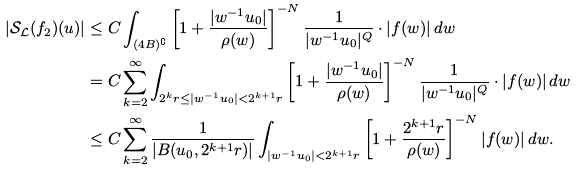Convert formula to latex. <formula><loc_0><loc_0><loc_500><loc_500>\left | \mathcal { S } _ { \mathcal { L } } ( f _ { 2 } ) ( u ) \right | & \leq C \int _ { ( 4 B ) ^ { \complement } } \left [ 1 + \frac { | w ^ { - 1 } u _ { 0 } | } { \rho ( w ) } \right ] ^ { - N } \frac { 1 } { | w ^ { - 1 } u _ { 0 } | ^ { Q } } \cdot | f ( w ) | \, d w \\ & = C \sum _ { k = 2 } ^ { \infty } \int _ { 2 ^ { k } r \leq | w ^ { - 1 } u _ { 0 } | < 2 ^ { k + 1 } r } \left [ 1 + \frac { | w ^ { - 1 } u _ { 0 } | } { \rho ( w ) } \right ] ^ { - N } \frac { 1 } { | w ^ { - 1 } u _ { 0 } | ^ { Q } } \cdot | f ( w ) | \, d w \\ & \leq C \sum _ { k = 2 } ^ { \infty } \frac { 1 } { | B ( u _ { 0 } , 2 ^ { k + 1 } r ) | } \int _ { | w ^ { - 1 } u _ { 0 } | < 2 ^ { k + 1 } r } \left [ 1 + \frac { 2 ^ { k + 1 } r } { \rho ( w ) } \right ] ^ { - N } | f ( w ) | \, d w .</formula> 